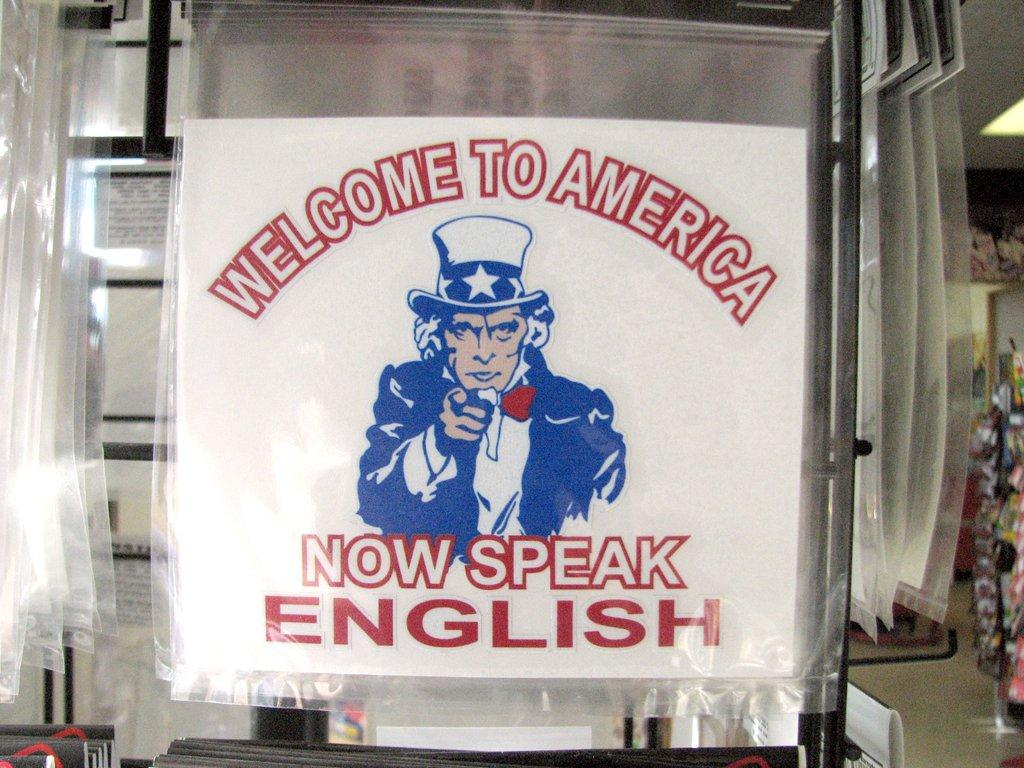<image>
Create a compact narrative representing the image presented. A large sign with Uncle Sam pointing at us says Welcome to America, now speak English. 